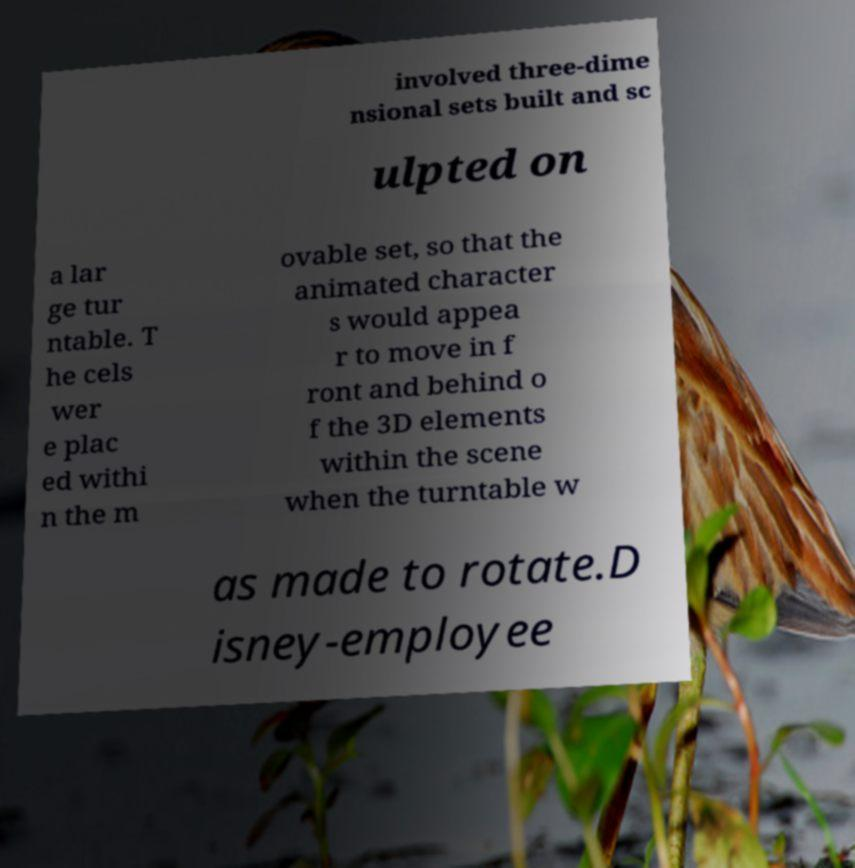For documentation purposes, I need the text within this image transcribed. Could you provide that? involved three-dime nsional sets built and sc ulpted on a lar ge tur ntable. T he cels wer e plac ed withi n the m ovable set, so that the animated character s would appea r to move in f ront and behind o f the 3D elements within the scene when the turntable w as made to rotate.D isney-employee 